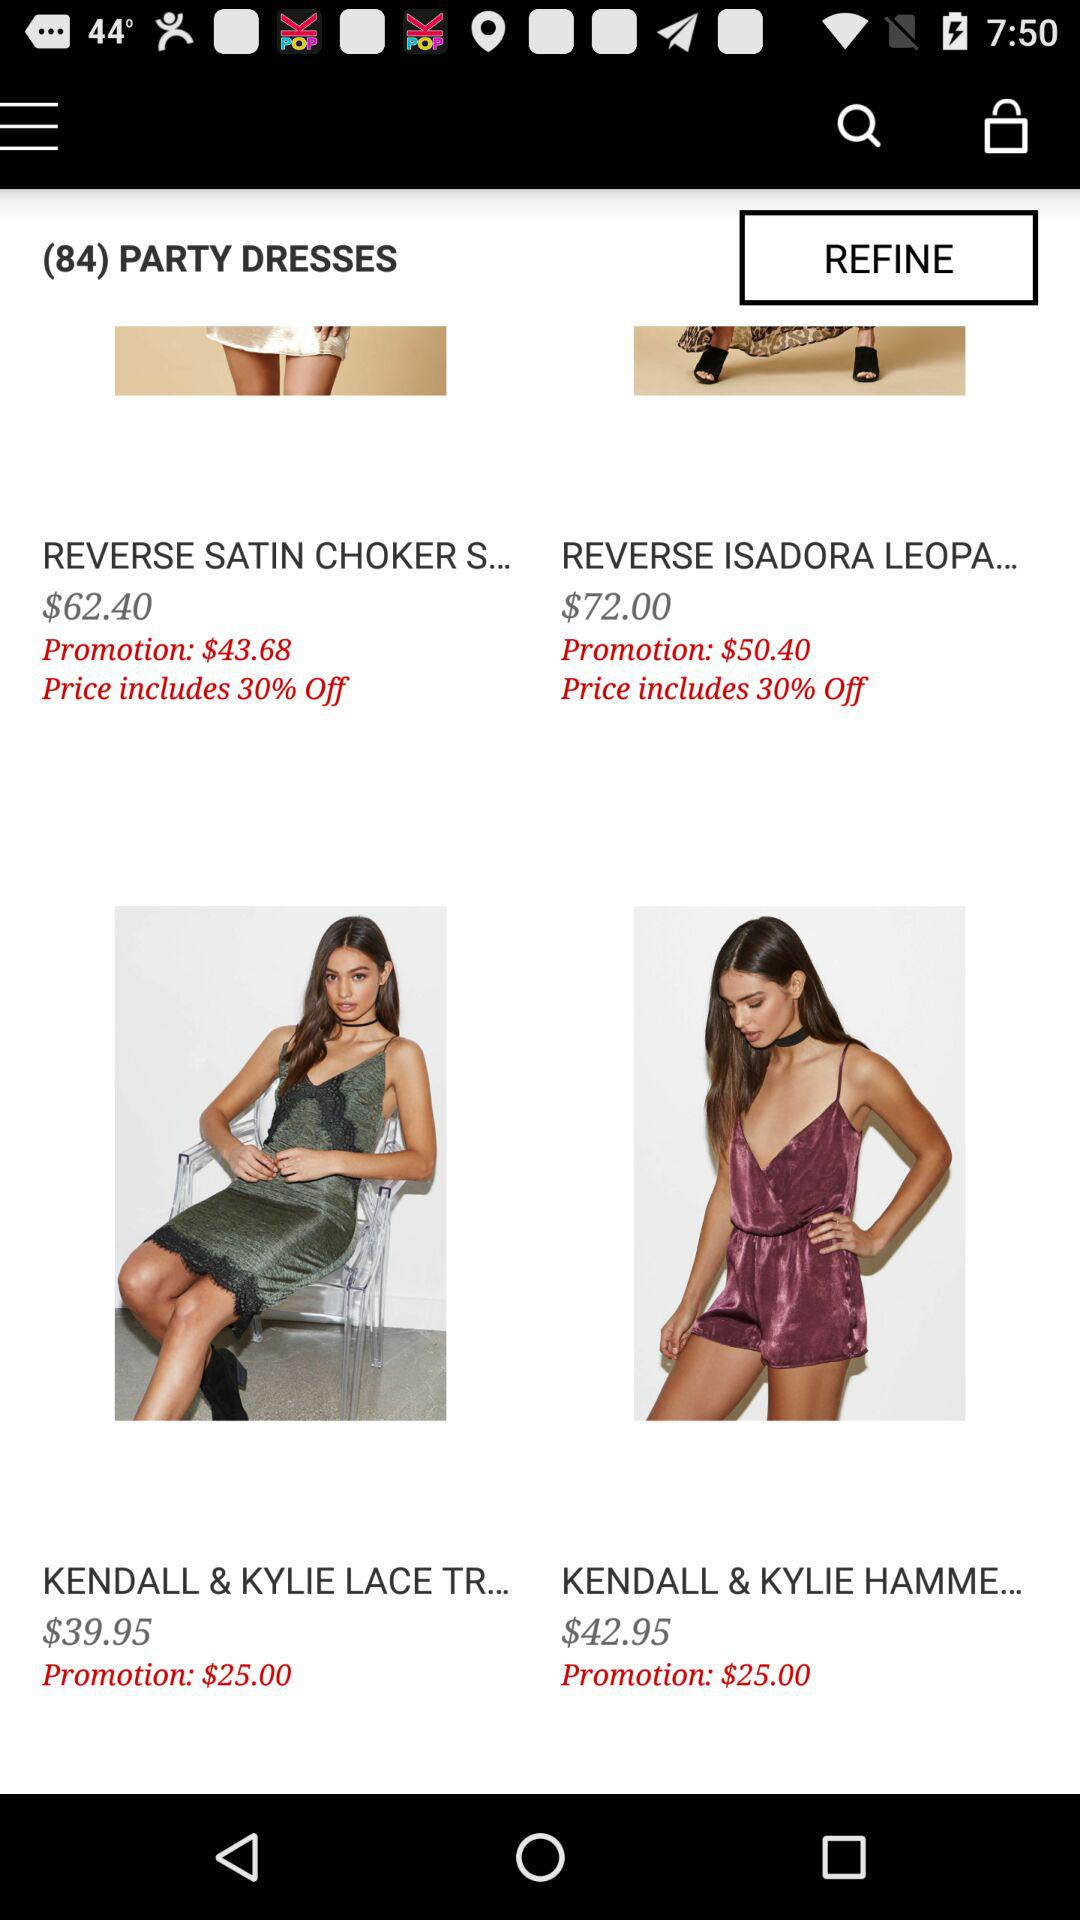How much discount is included in the price of the reverse satin choker? The discount included in the price of the reverse satin choker is 30 percent. 